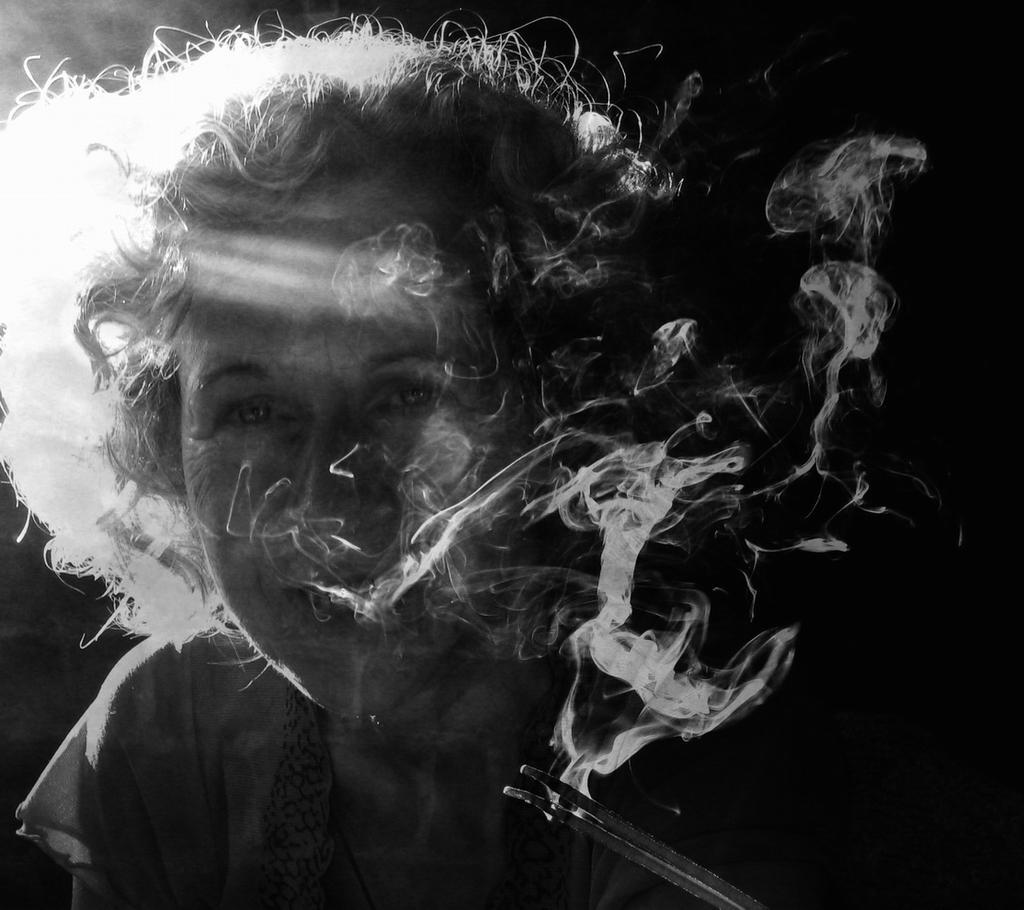In one or two sentences, can you explain what this image depicts? In the foreground of this picture we can see a person seems to be sitting. At the bottom there is an object which seems to be releasing the smoke. The background of the image is dark. 